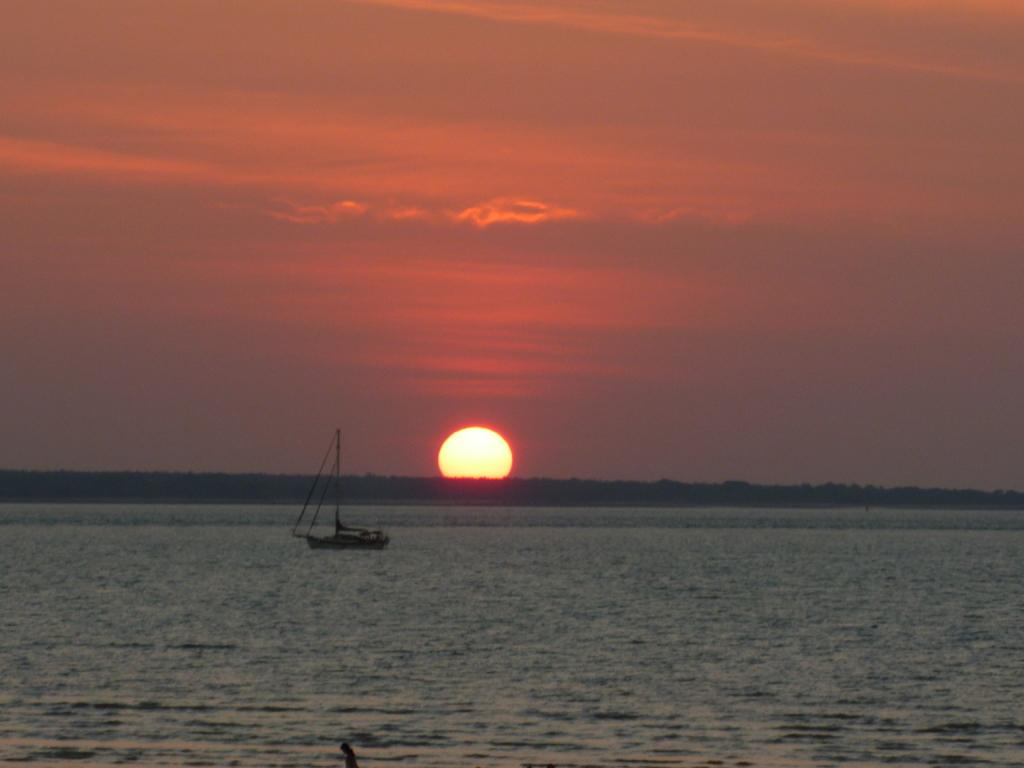What is the main subject of the image? The main subject of the image is a boat. Where is the boat located? The boat is on water. What can be seen in the background of the image? The background of the image includes the sun. What is the color of the sky in the image? The sky is orange in color. What type of apparel is the boat wearing in the image? Boats do not wear apparel, as they are inanimate objects. 